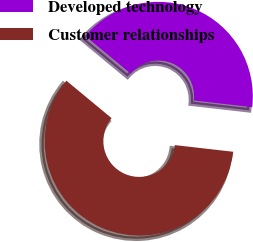Convert chart. <chart><loc_0><loc_0><loc_500><loc_500><pie_chart><fcel>Developed technology<fcel>Customer relationships<nl><fcel>40.8%<fcel>59.2%<nl></chart> 